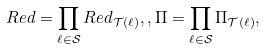Convert formula to latex. <formula><loc_0><loc_0><loc_500><loc_500>R e d = \prod _ { \ell \in \mathcal { S } } R e d _ { \mathcal { T } ( \ell ) } , , \Pi = \prod _ { \ell \in \mathcal { S } } \Pi _ { \mathcal { T } ( \ell ) } ,</formula> 